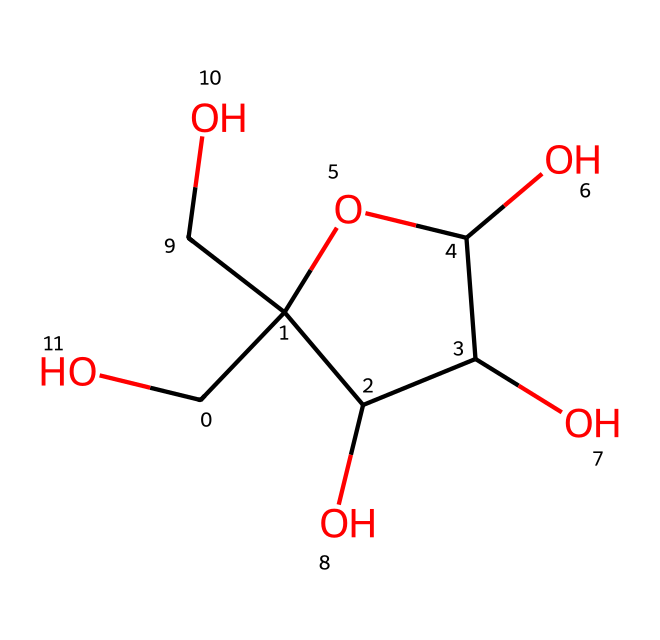How many carbon atoms are in fructose? By analyzing the SMILES representation, we can count the carbon atoms represented. Each "C" corresponds to a carbon atom, and in this structure, there are six "C" which means six carbon atoms.
Answer: six What is the functional group present in this structure? The presence of multiple -OH (hydroxyl) groups is evident from the structure, indicating that this compound is a sugar alcohol. The glucose fragment contributes several hydroxyl groups thus confirming the sugar classification.
Answer: hydroxyl Is fructose a monosaccharide or disaccharide? The structure shows a single sugar unit without any other linked monosaccharides. Therefore, it is classified as a monosaccharide.
Answer: monosaccharide What kind of carbohydrate is fructose? The structure and its function as a simple sugar classify it as a ketose due to the positioning of its carbonyl group (>C=O) within the carbon chain, specifically at the second carbon.
Answer: ketose What is the total number of hydroxyl groups in fructose? By systematically counting the -OH groups in the SMILES formula, we identify that there are five hydroxyl (-OH) groups present in the structure.
Answer: five In what common beverage is fructose often found? Fructose is naturally found in sweet tea, especially in Southern culture where it is a primary source of sweetness, as tea is frequently sweetened with sugar, which includes fructose.
Answer: sweet tea 